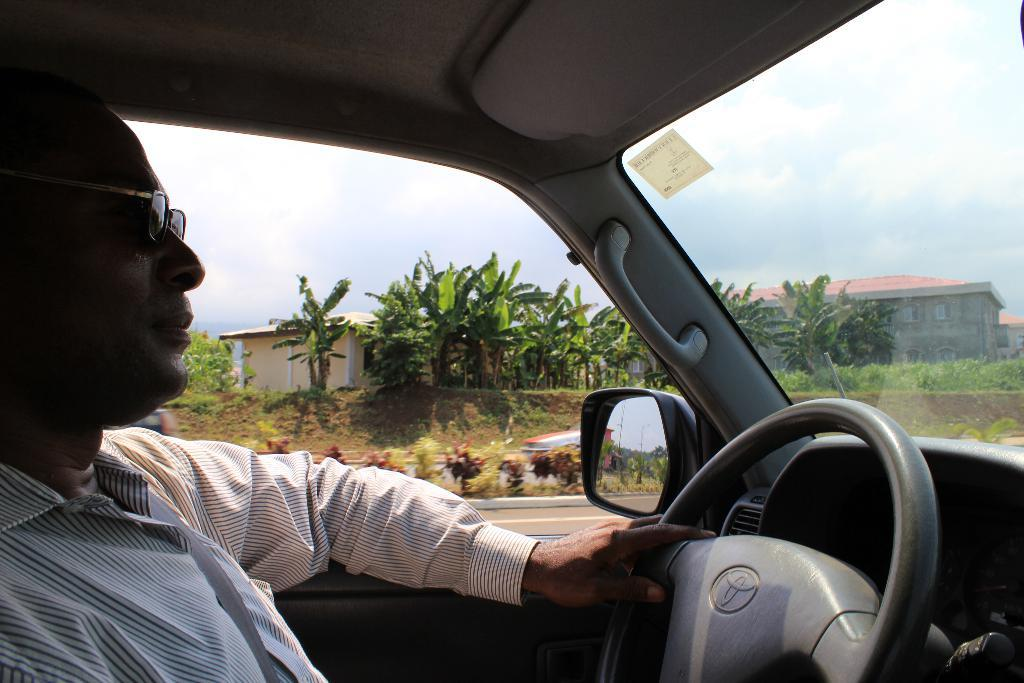What is the main subject of the image? There is a person in the image. What can be observed about the person's appearance? The person is wearing glasses (specs). What is the person doing in the image? The person is holding the steering wheel of a car. What can be seen in the background of the image? There are plants, buildings, and the sky visible in the background of the image. What is the weather like in the image? The sky has clouds, which suggests that it might be partly cloudy. What type of joke is the person telling in the image? There is no indication in the image that the person is telling a joke, so it cannot be determined from the picture. 